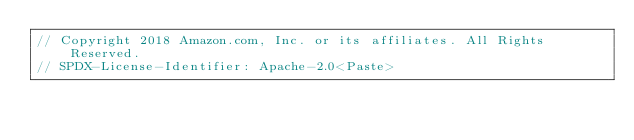<code> <loc_0><loc_0><loc_500><loc_500><_Rust_>// Copyright 2018 Amazon.com, Inc. or its affiliates. All Rights Reserved.
// SPDX-License-Identifier: Apache-2.0<Paste>
</code> 